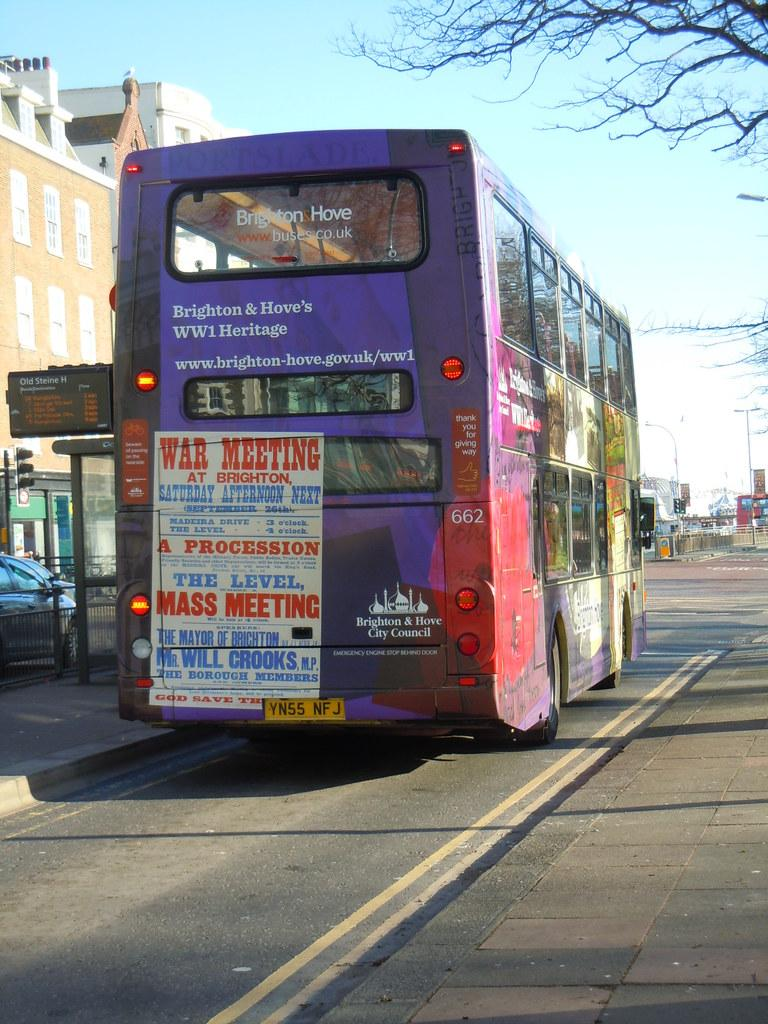What type of vehicle is the main subject in the image? There is a bus in the image. What else can be seen on the road in the image? There are cars on the road in the image. What helps regulate traffic in the image? There are traffic lights in the image. What type of structures are visible in the image? There are buildings in the image. What can be seen in the background of the image? There are poles and trees in the background of the image. What type of glass is used to make the ring in the image? There is no ring or glass present in the image; it features a bus, cars, traffic lights, buildings, poles, and trees. 